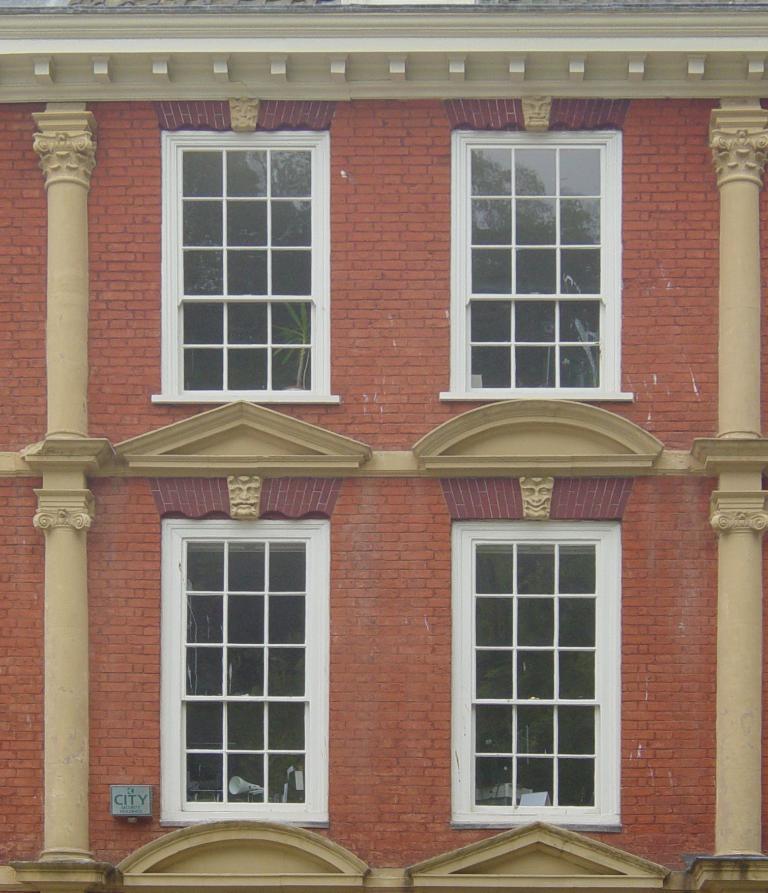How would you summarize this image in a sentence or two? In this picture I can observe a building. On either sides of the picture I can observe pillars. I can observe four windows in this building. 